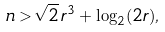<formula> <loc_0><loc_0><loc_500><loc_500>n > \sqrt { 2 } \, r ^ { 3 } + \log _ { 2 } ( 2 r ) ,</formula> 